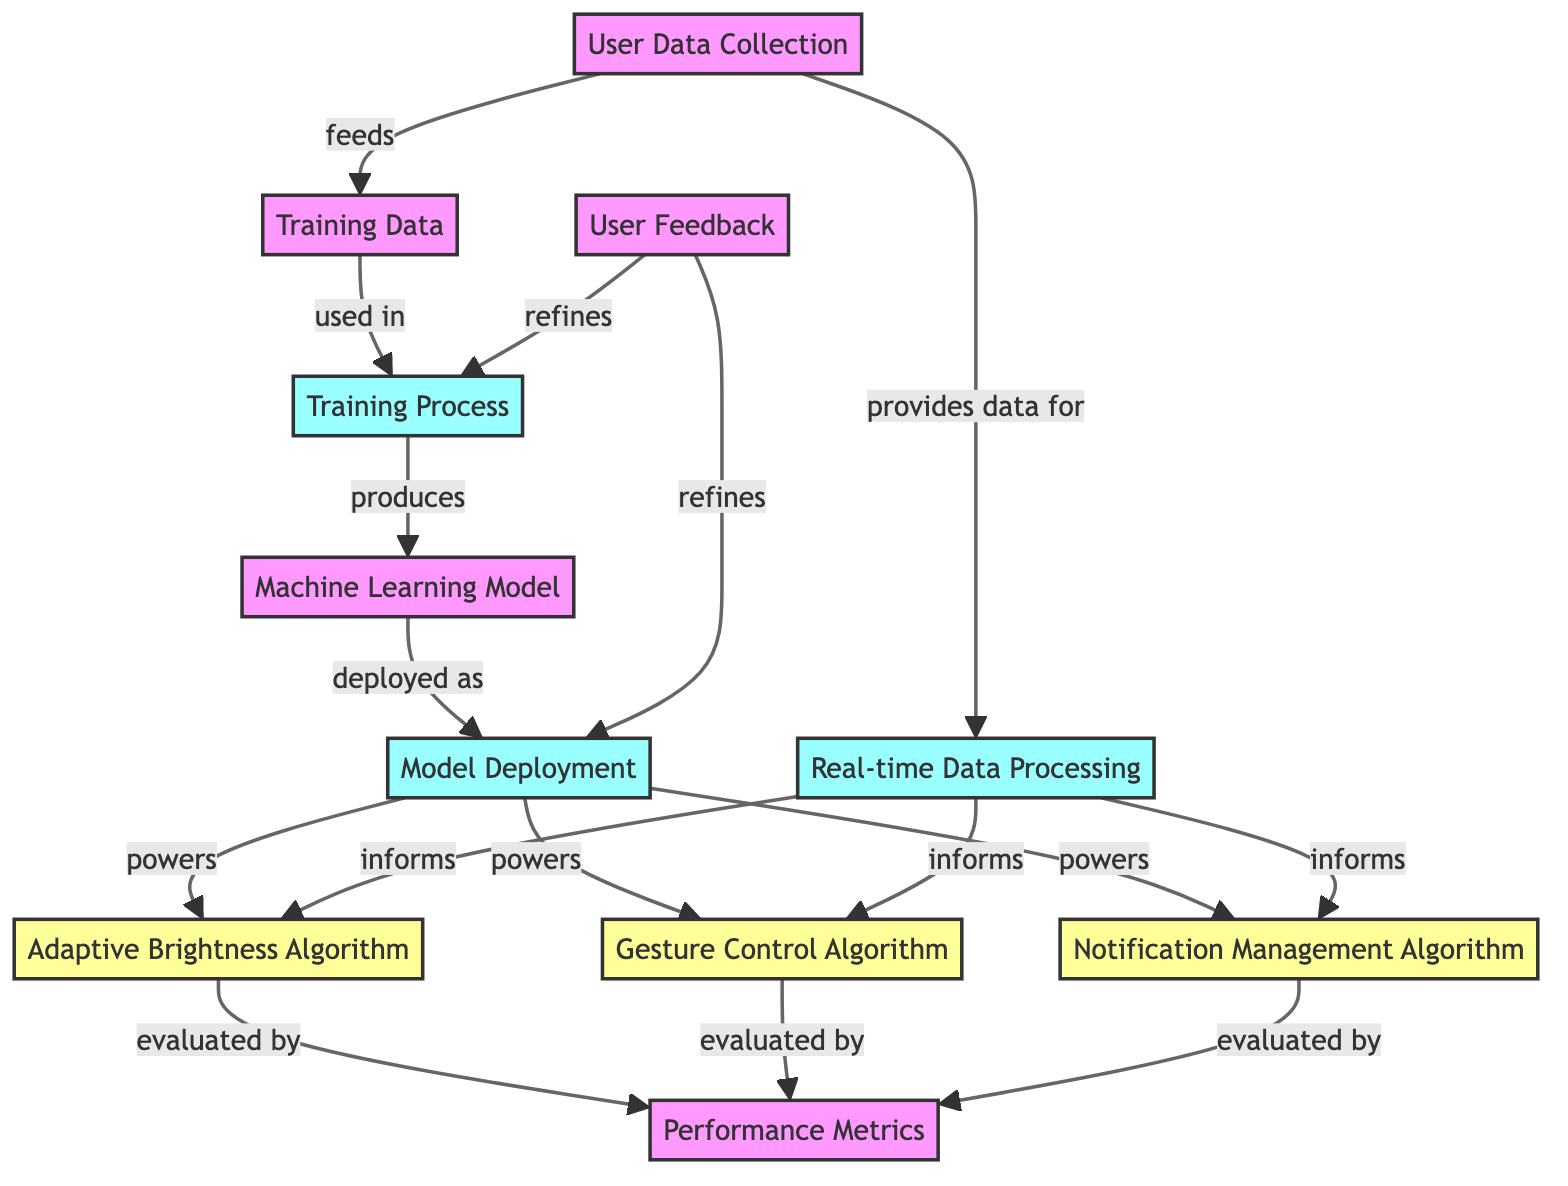What is the first step in the diagram? The diagram begins with "User Data Collection," which is the first labeled node in the flow.
Answer: User Data Collection How many algorithms are shown in the diagram? There are three algorithms indicated in the diagram: Adaptive Brightness Algorithm, Gesture Control Algorithm, and Notification Management Algorithm.
Answer: Three Which node is evaluated by performance metrics? All three algorithms (Adaptive Brightness, Gesture Control, and Notification Management) are linked to the Performance Metrics node, indicating they are evaluated by this node.
Answer: Adaptive Brightness Algorithm, Gesture Control Algorithm, Notification Management Algorithm What feeds into the Training Data node? The "User Data Collection" node feeds into the "Training Data" node, representing the flow of information from user data to the training data needed for the algorithms.
Answer: User Data Collection What powers the Gesture Control Algorithm? The Gesture Control Algorithm is powered by the "Model Deployment" node, which indicates that the deployed machine learning model drives the algorithm's functionality.
Answer: Model Deployment Which process uses real-time data processing? The "Real-time Data Processing" node informs all three algorithms, indicating that it plays a role in their adjustment and functioning in real times, such as adapting to user interaction.
Answer: Adaptive Brightness Algorithm, Gesture Control Algorithm, Notification Management Algorithm How does user feedback influence the diagram? "User Feedback" refines both the "Training Process" and "Model Deployment," indicating that feedback from users helps improve the training of the algorithms and enhances the deployed model's performance.
Answer: Refines Training Process and Model Deployment What is the output of the Training Process? The output of the "Training Process" is the "Machine Learning Model," which results from the training phase utilizing the training data collected.
Answer: Machine Learning Model What relationship exists between the "Model Deployment" and the algorithms? The "Model Deployment" powers all three algorithms, meaning that the deployed machine learning model directly influences their functionality.
Answer: Powers all algorithms 